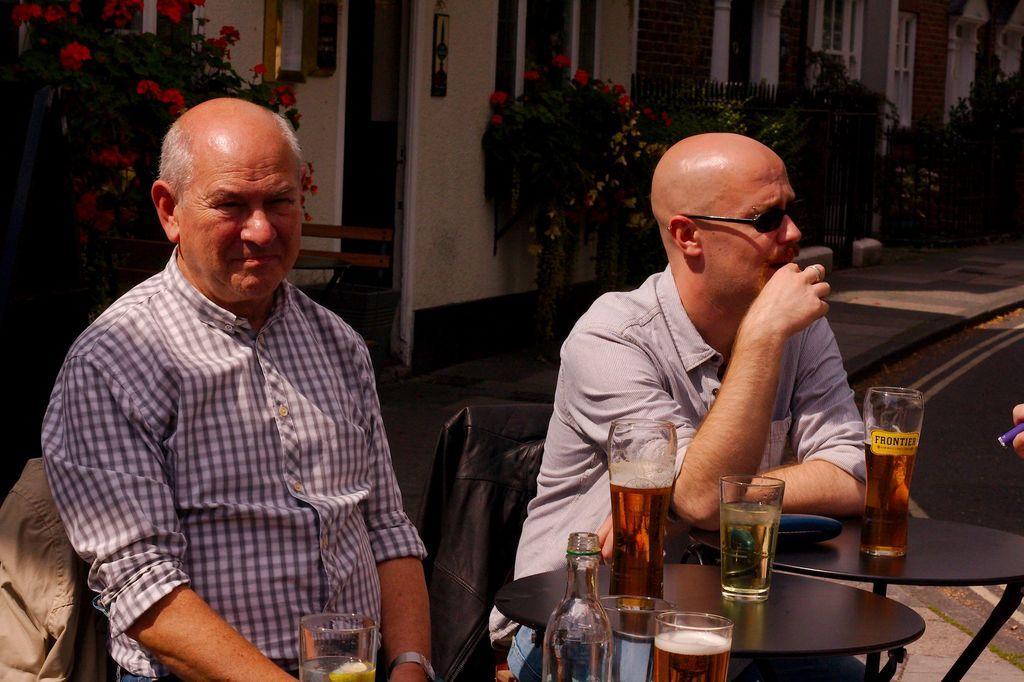Describe this image in one or two sentences. In this image we can see two persons sitting in front of a table. One person is wearing goggles. On the table we can see several glasses filled with liquid in it. In the background, we can see group of plants, metal fence and buildings. 